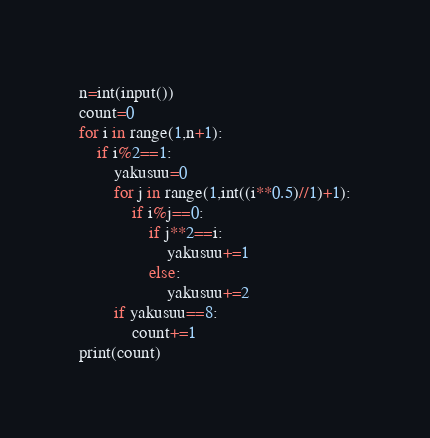<code> <loc_0><loc_0><loc_500><loc_500><_Python_>n=int(input())
count=0
for i in range(1,n+1):
    if i%2==1:
        yakusuu=0
        for j in range(1,int((i**0.5)//1)+1):
            if i%j==0:
                if j**2==i:
                    yakusuu+=1
                else:
                    yakusuu+=2
        if yakusuu==8:
            count+=1
print(count)</code> 